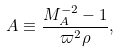<formula> <loc_0><loc_0><loc_500><loc_500>\ A \equiv \frac { M _ { A } ^ { - 2 } - 1 } { \varpi ^ { 2 } \rho } ,</formula> 